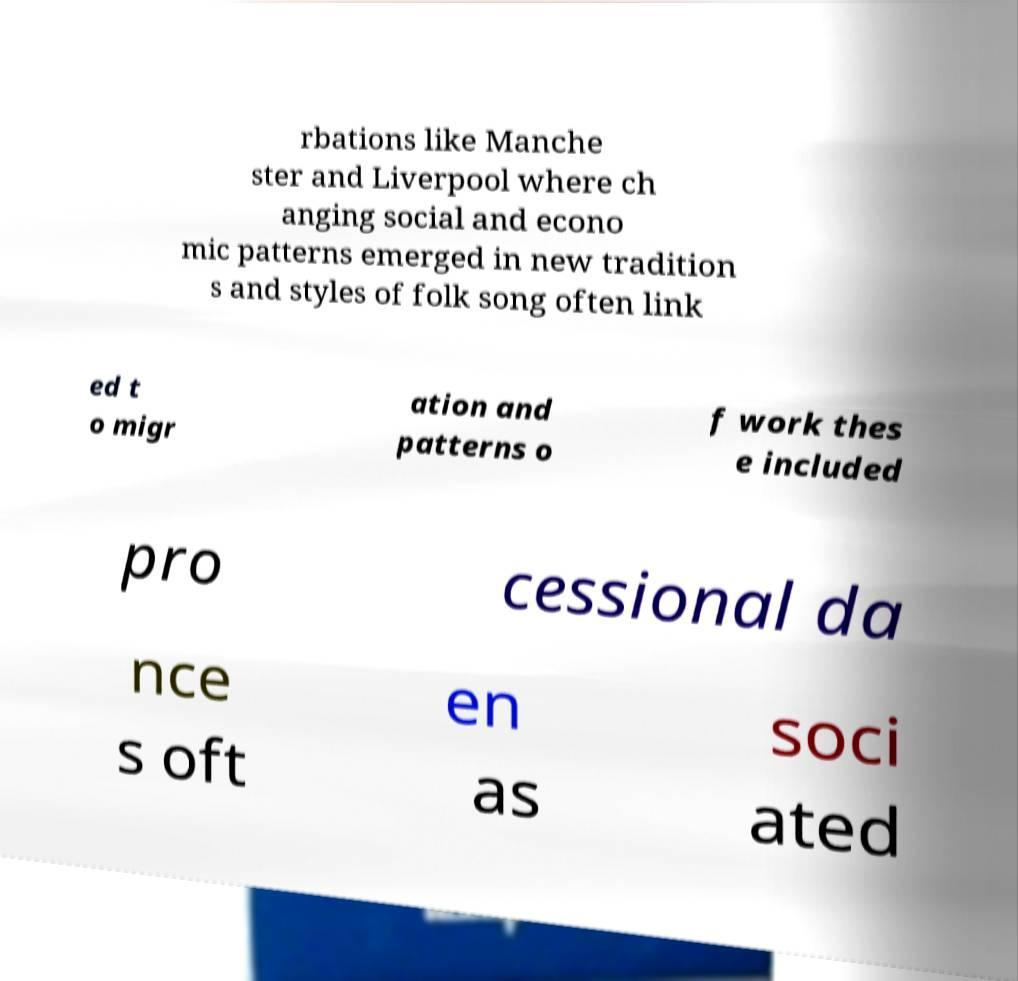I need the written content from this picture converted into text. Can you do that? rbations like Manche ster and Liverpool where ch anging social and econo mic patterns emerged in new tradition s and styles of folk song often link ed t o migr ation and patterns o f work thes e included pro cessional da nce s oft en as soci ated 